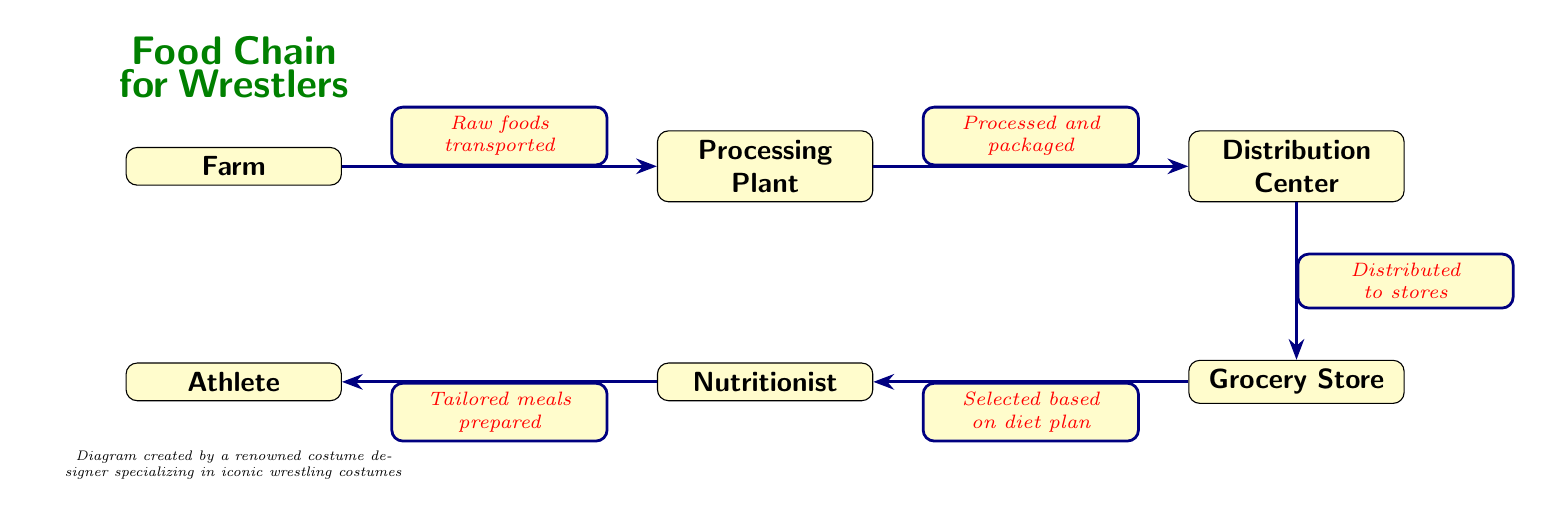What is the first node in the food chain? The first node in the food chain is "Farm," indicating where raw foods originate before being processed.
Answer: Farm How many nodes are in the food chain? To find the number of nodes, we count each labeled box in the diagram: Farm, Processing Plant, Distribution Center, Grocery Store, Nutritionist, and Athlete, totaling six nodes.
Answer: Six What kind of foods are transported from the farm? The diagram specifies that "Raw foods" are transported from the farm to the processing plant, encapsulating the initial step in the food chain focused on nutrition for athletes.
Answer: Raw foods What is the relationship between the grocery store and the nutritionist? The grocery store connects to the nutritionist with the label "Selected based on diet plan," suggesting that the nutritionist chooses food from the grocery store according to the athlete's dietary needs.
Answer: Selected based on diet plan What is tailored at the end of the food chain? At the end of the food chain, the nutritionist prepares "Tailored meals," indicating personalized dietary solutions for the athlete to enhance performance.
Answer: Tailored meals Which node comes directly before the athlete? The node that comes directly before the athlete is the nutritionist, indicating that the tailored meals are prepared right before they reach the athlete for consumption.
Answer: Nutritionist What does the processing plant provide? The processing plant provides "Processed and packaged" foods, as indicated by the label on the edge connecting it to the distribution center, emphasizing the transformation of raw foods.
Answer: Processed and packaged What is transported to the grocery store? The items that are transported to the grocery store are "Distributed to stores," highlighting the logistic step from the distribution center to the retail environment.
Answer: Distributed to stores What is the role of the distribution center in this food chain? The distribution center serves to distribute the processed food to grocery stores, facilitating the availability of nutrition-rich foods for athletes' diets.
Answer: Distributed to stores 